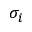<formula> <loc_0><loc_0><loc_500><loc_500>\sigma _ { i }</formula> 